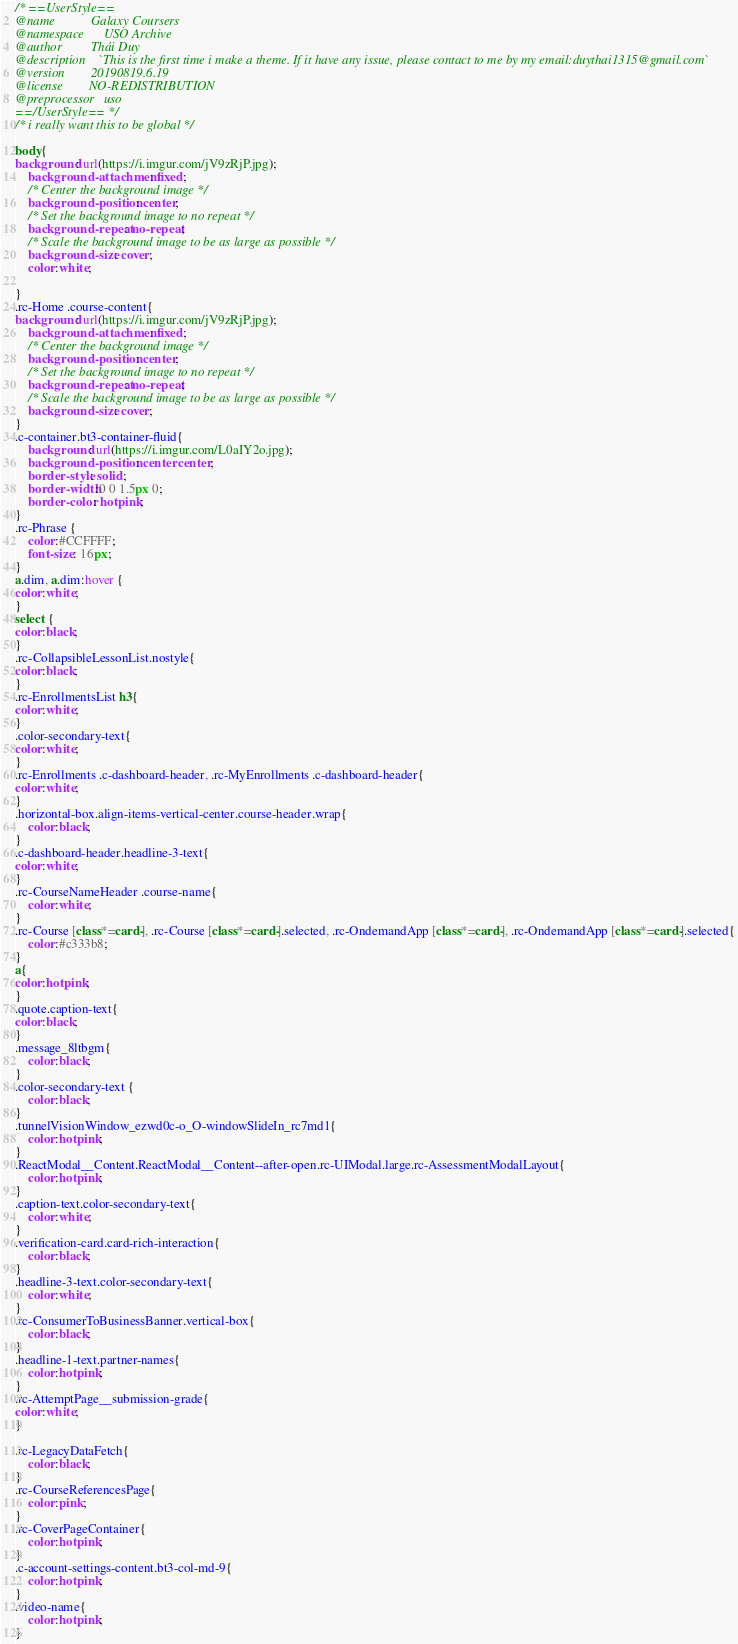<code> <loc_0><loc_0><loc_500><loc_500><_CSS_>/* ==UserStyle==
@name           Galaxy Coursers
@namespace      USO Archive
@author         Thái Duy
@description    `This is the first time i make a theme. If it have any issue, please contact to me by my email:duythai1315@gmail.com`
@version        20190819.6.19
@license        NO-REDISTRIBUTION
@preprocessor   uso
==/UserStyle== */
/* i really want this to be global */

body{
background: url(https://i.imgur.com/jV9zRjP.jpg);
    background-attachment: fixed;
    /* Center the background image */
    background-position: center;
    /* Set the background image to no repeat */
    background-repeat: no-repeat;
    /* Scale the background image to be as large as possible */
    background-size: cover;
    color:white;

}
.rc-Home .course-content{
background: url(https://i.imgur.com/jV9zRjP.jpg);
    background-attachment: fixed;
    /* Center the background image */
    background-position: center;
    /* Set the background image to no repeat */
    background-repeat: no-repeat;
    /* Scale the background image to be as large as possible */
    background-size: cover;
}
.c-container.bt3-container-fluid{
    background: url(https://i.imgur.com/L0aIY2o.jpg);
    background-position: center center;
	border-style: solid;
	border-width:0 0 1.5px 0;
    border-color: hotpink;
}
.rc-Phrase {
    color:#CCFFFF;
    font-size: 16px;
}
a.dim, a.dim:hover {
color:white;
}
select {
color:black;
}
.rc-CollapsibleLessonList.nostyle{
color:black;
}
.rc-EnrollmentsList h3{
color:white;
}
.color-secondary-text{
color:white;
}
.rc-Enrollments .c-dashboard-header, .rc-MyEnrollments .c-dashboard-header{
color:white;
}
.horizontal-box.align-items-vertical-center.course-header.wrap{
    color:black;
}
.c-dashboard-header.headline-3-text{
color:white;
}
.rc-CourseNameHeader .course-name{
	color:white;
}
.rc-Course [class*=card-], .rc-Course [class*=card-].selected, .rc-OndemandApp [class*=card-], .rc-OndemandApp [class*=card-].selected{
	color:#c333b8;
}
a{
color:hotpink;
}
.quote.caption-text{
color:black;
}
.message_8ltbgm{
	color:black;
}
.color-secondary-text {
	color:black;
}
.tunnelVisionWindow_ezwd0c-o_O-windowSlideIn_rc7md1{
	color:hotpink;
}
.ReactModal__Content.ReactModal__Content--after-open.rc-UIModal.large.rc-AssessmentModalLayout{
    color:hotpink;
}
.caption-text.color-secondary-text{
	color:white;
}
.verification-card.card-rich-interaction{
    color:black;
}
.headline-3-text.color-secondary-text{
	color:white;
}
.rc-ConsumerToBusinessBanner.vertical-box{
	color:black;
}
.headline-1-text.partner-names{
	color:hotpink;
}
.rc-AttemptPage__submission-grade{
color:white;
}

.rc-LegacyDataFetch{
	color:black;
}
.rc-CourseReferencesPage{
	color:pink;
}
.rc-CoverPageContainer{
	color:hotpink;
}
.c-account-settings-content.bt3-col-md-9{
	color:hotpink;
}
.video-name{
	color:hotpink;
}</code> 